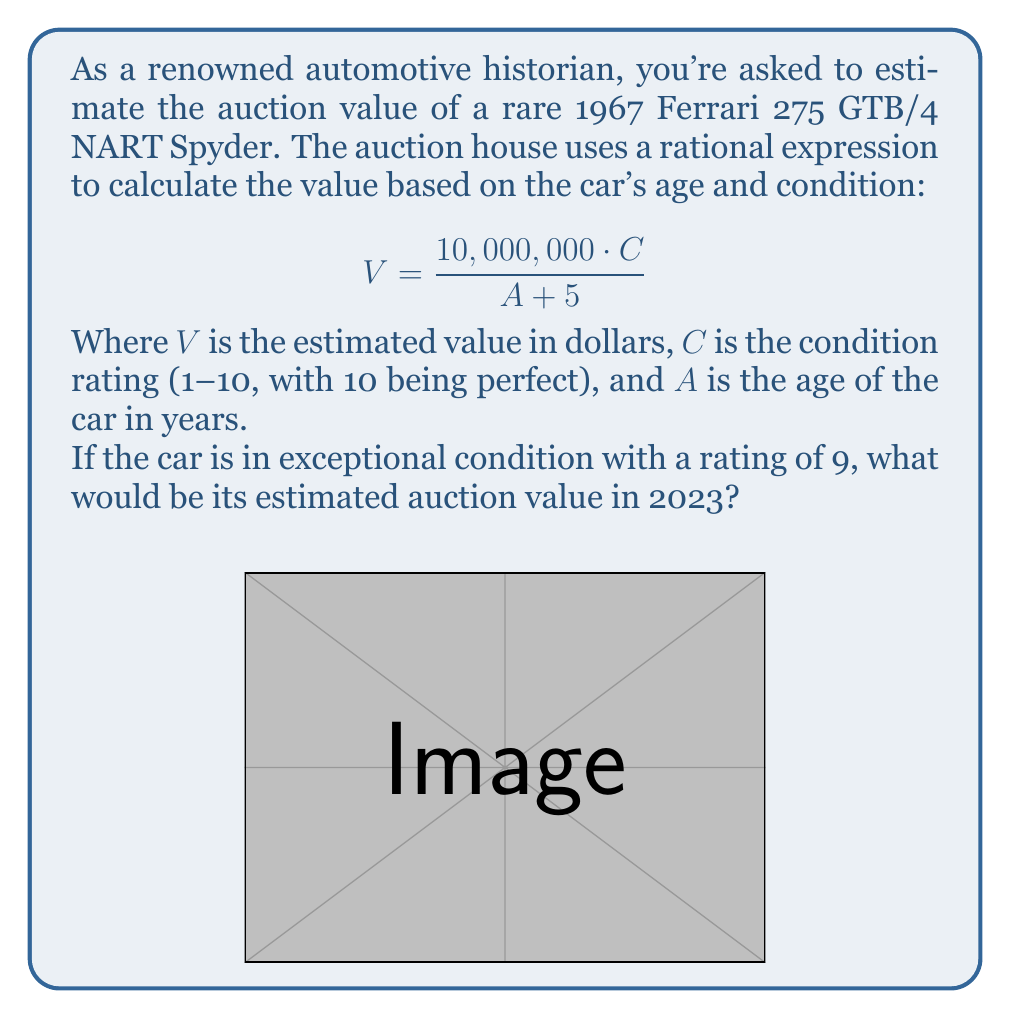Provide a solution to this math problem. To solve this problem, we'll follow these steps:

1. Identify the given information:
   - The car is a 1967 Ferrari 275 GTB/4 NART Spyder
   - The condition rating (C) is 9
   - The current year is 2023

2. Calculate the age of the car (A):
   $A = 2023 - 1967 = 56$ years

3. Substitute the values into the rational expression:
   $$V = \frac{10,000,000 \cdot C}{A + 5}$$
   $$V = \frac{10,000,000 \cdot 9}{56 + 5}$$

4. Simplify the numerator and denominator:
   $$V = \frac{90,000,000}{61}$$

5. Perform the division:
   $$V = 1,475,409.84$$

6. Round to the nearest dollar:
   $$V ≈ 1,475,410$$

Therefore, the estimated auction value of the 1967 Ferrari 275 GTB/4 NART Spyder in 2023 would be approximately $1,475,410.
Answer: $1,475,410 